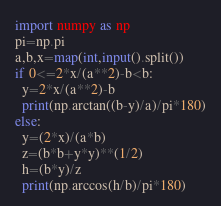Convert code to text. <code><loc_0><loc_0><loc_500><loc_500><_Python_>import numpy as np
pi=np.pi
a,b,x=map(int,input().split())
if 0<=2*x/(a**2)-b<b:
  y=2*x/(a**2)-b
  print(np.arctan((b-y)/a)/pi*180)
else:
  y=(2*x)/(a*b)
  z=(b*b+y*y)**(1/2)
  h=(b*y)/z
  print(np.arccos(h/b)/pi*180)</code> 